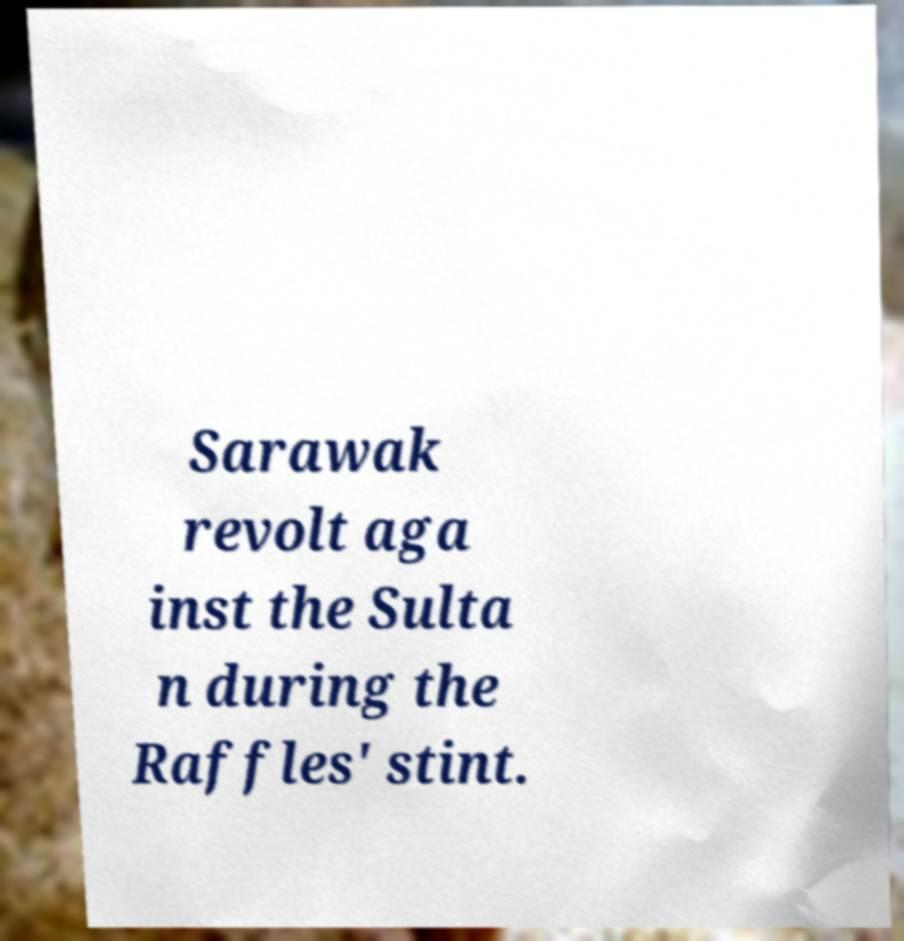Could you assist in decoding the text presented in this image and type it out clearly? Sarawak revolt aga inst the Sulta n during the Raffles' stint. 